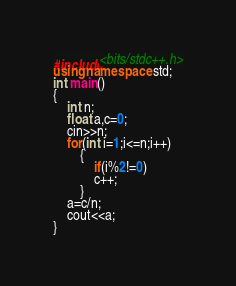Convert code to text. <code><loc_0><loc_0><loc_500><loc_500><_C++_>#include<bits/stdc++.h>
using namespace std;
int main()
{
    int n;
    float a,c=0;
    cin>>n;
    for(int i=1;i<=n;i++)
        {
            if(i%2!=0)
            c++;
        }
    a=c/n;
    cout<<a;
}
</code> 